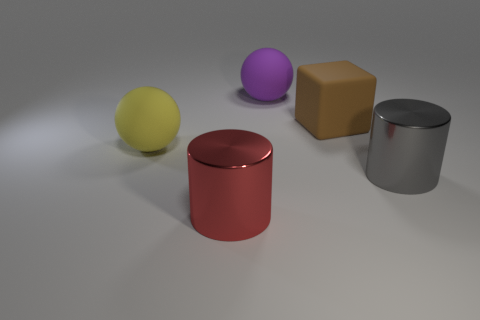There is a metallic object behind the big red shiny thing; is its shape the same as the purple object?
Keep it short and to the point. No. What number of things are either large yellow rubber things or big metal cylinders?
Offer a terse response. 3. Do the big block that is right of the red cylinder and the big purple ball have the same material?
Keep it short and to the point. Yes. What is the size of the brown matte object?
Make the answer very short. Large. How many cylinders are either tiny purple rubber things or matte objects?
Your response must be concise. 0. Is the number of big gray cylinders that are left of the gray cylinder the same as the number of large matte spheres that are on the right side of the yellow thing?
Your response must be concise. No. The other thing that is the same shape as the large purple rubber object is what size?
Your answer should be very brief. Large. There is a rubber thing that is both in front of the purple ball and to the right of the large yellow matte sphere; how big is it?
Provide a short and direct response. Large. Are there any big yellow things behind the purple rubber thing?
Your answer should be very brief. No. What number of objects are large matte balls that are on the right side of the red metallic object or small purple matte blocks?
Provide a succinct answer. 1. 